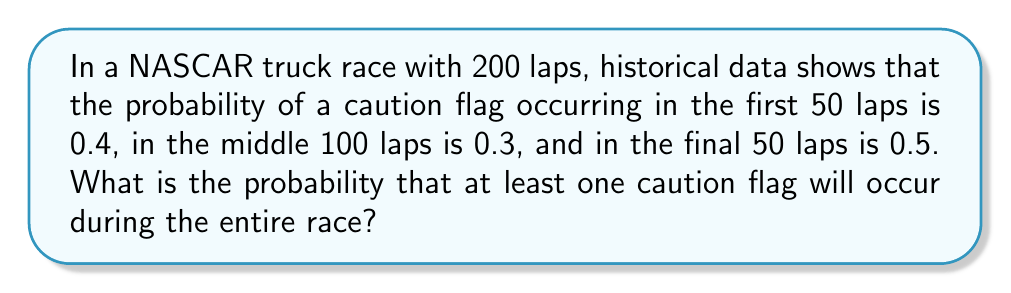Teach me how to tackle this problem. Let's approach this step-by-step:

1) First, we need to calculate the probability of no caution flags occurring in each stage of the race.

   For the first 50 laps: $P(\text{no caution}) = 1 - 0.4 = 0.6$
   For the middle 100 laps: $P(\text{no caution}) = 1 - 0.3 = 0.7$
   For the final 50 laps: $P(\text{no caution}) = 1 - 0.5 = 0.5$

2) The probability of no caution flags occurring during the entire race is the product of these probabilities:

   $P(\text{no caution in entire race}) = 0.6 \times 0.7 \times 0.5 = 0.21$

3) Therefore, the probability of at least one caution flag occurring is the complement of this probability:

   $P(\text{at least one caution}) = 1 - P(\text{no caution in entire race})$
   $= 1 - 0.21 = 0.79$

4) We can express this as a percentage:

   $0.79 \times 100\% = 79\%$
Answer: 79% 